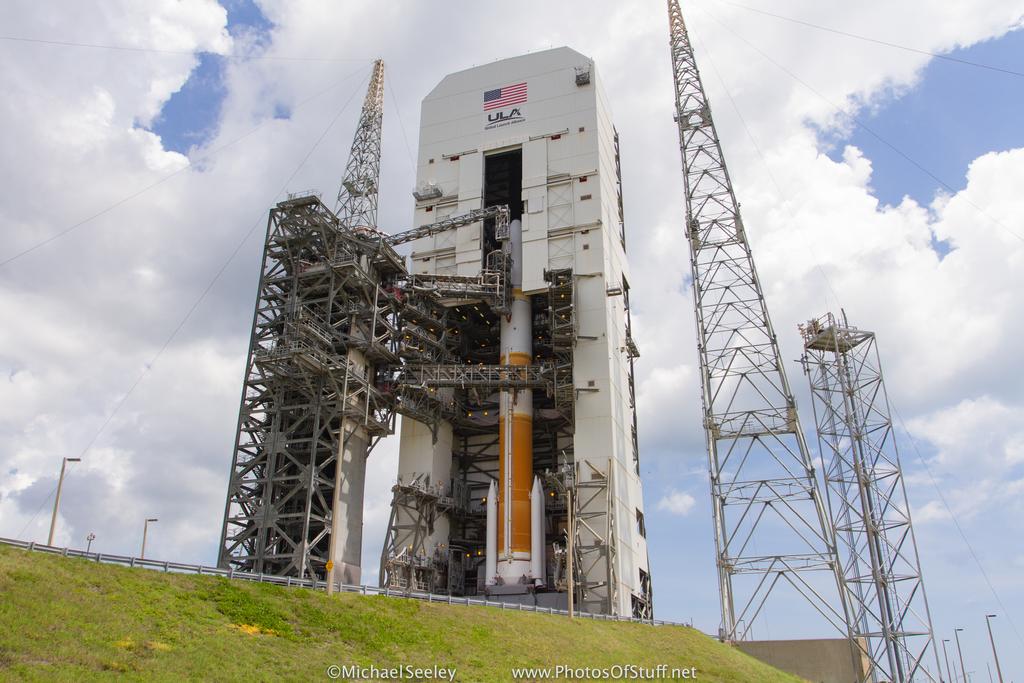What is below the american flag?
Offer a very short reply. Ula. 